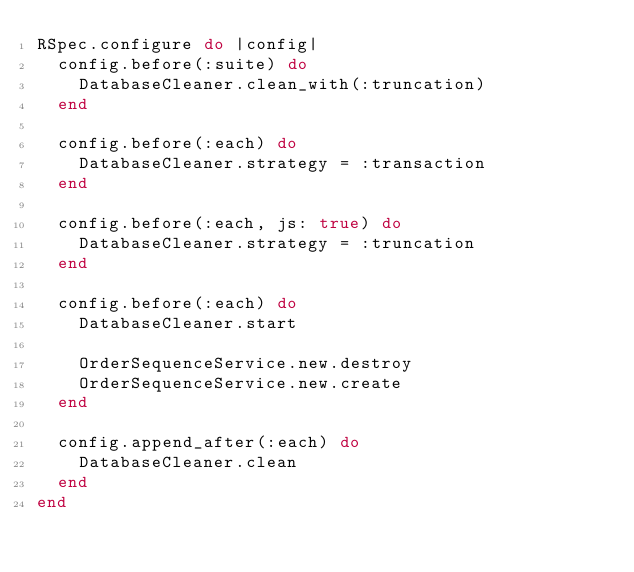<code> <loc_0><loc_0><loc_500><loc_500><_Ruby_>RSpec.configure do |config|
  config.before(:suite) do
    DatabaseCleaner.clean_with(:truncation)
  end

  config.before(:each) do
    DatabaseCleaner.strategy = :transaction
  end

  config.before(:each, js: true) do
    DatabaseCleaner.strategy = :truncation
  end

  config.before(:each) do
    DatabaseCleaner.start

    OrderSequenceService.new.destroy
    OrderSequenceService.new.create
  end

  config.append_after(:each) do
    DatabaseCleaner.clean
  end
end
</code> 